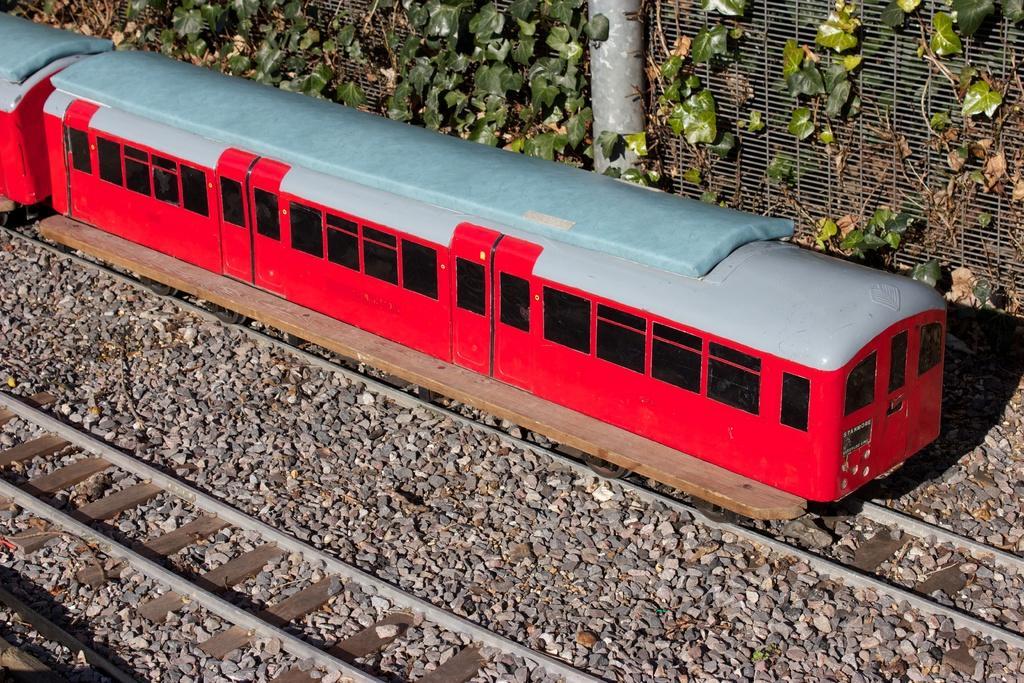Describe this image in one or two sentences. In this picture I can see the toys set, where I can see the tracks, a train, fencing and few plants. I can also see number of stones. 